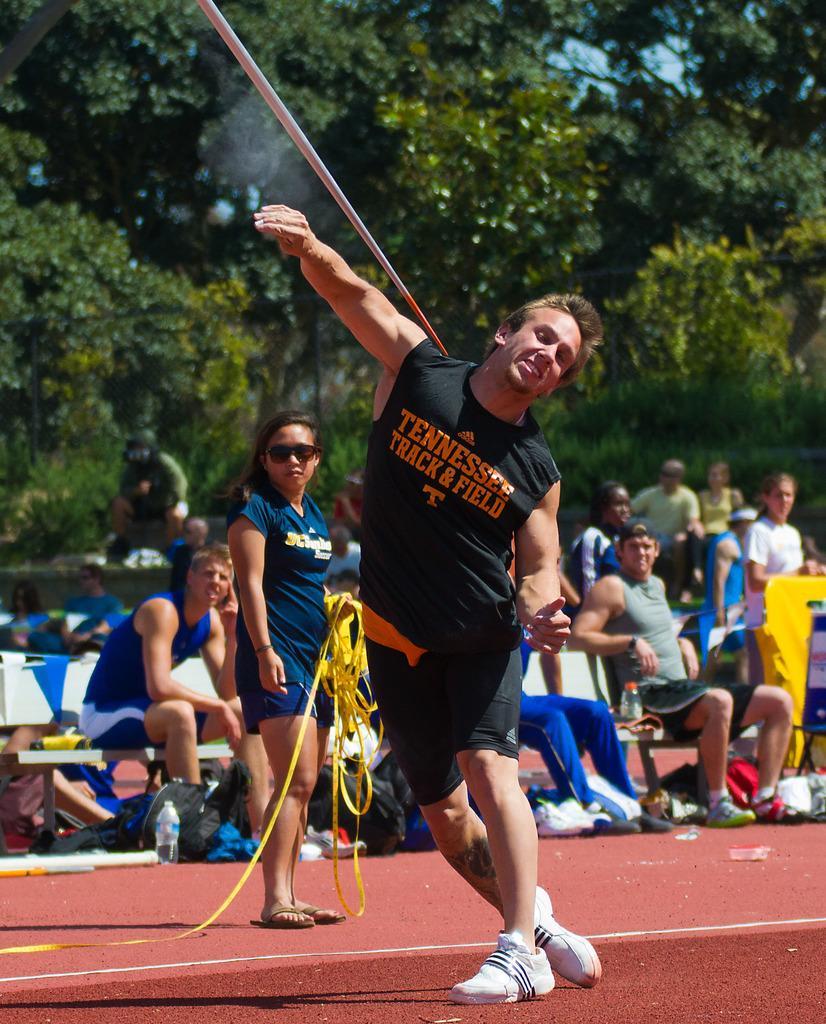Please provide a concise description of this image. This image consists of a person wearing black dress is playing javelin throw. At the bottom, there is floor. In the background, there are many people sitting. And there are many trees in the background. 